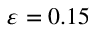<formula> <loc_0><loc_0><loc_500><loc_500>\varepsilon = 0 . 1 5</formula> 